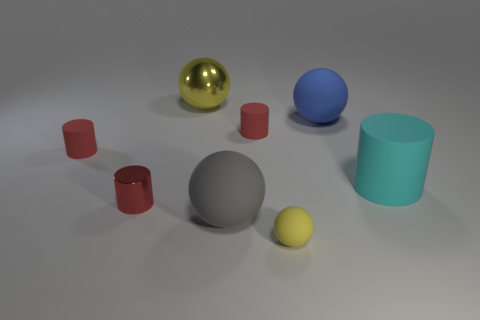How would you describe the composition and layout of the objects? The composition is somewhat sparse and random, with objects scattered across the frame without a clear pattern. The arrangement creates a sense of informal balance, avoiding symmetry, but still maintaining an aesthetically pleasing distribution of shapes and colors across the scene. 